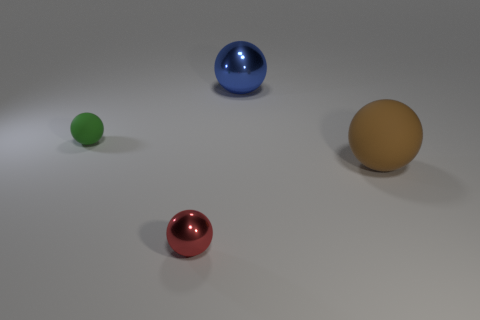Subtract 1 spheres. How many spheres are left? 3 Add 3 yellow rubber cylinders. How many objects exist? 7 Subtract all large blue things. Subtract all big brown things. How many objects are left? 2 Add 1 tiny balls. How many tiny balls are left? 3 Add 3 tiny brown matte cylinders. How many tiny brown matte cylinders exist? 3 Subtract 0 gray cylinders. How many objects are left? 4 